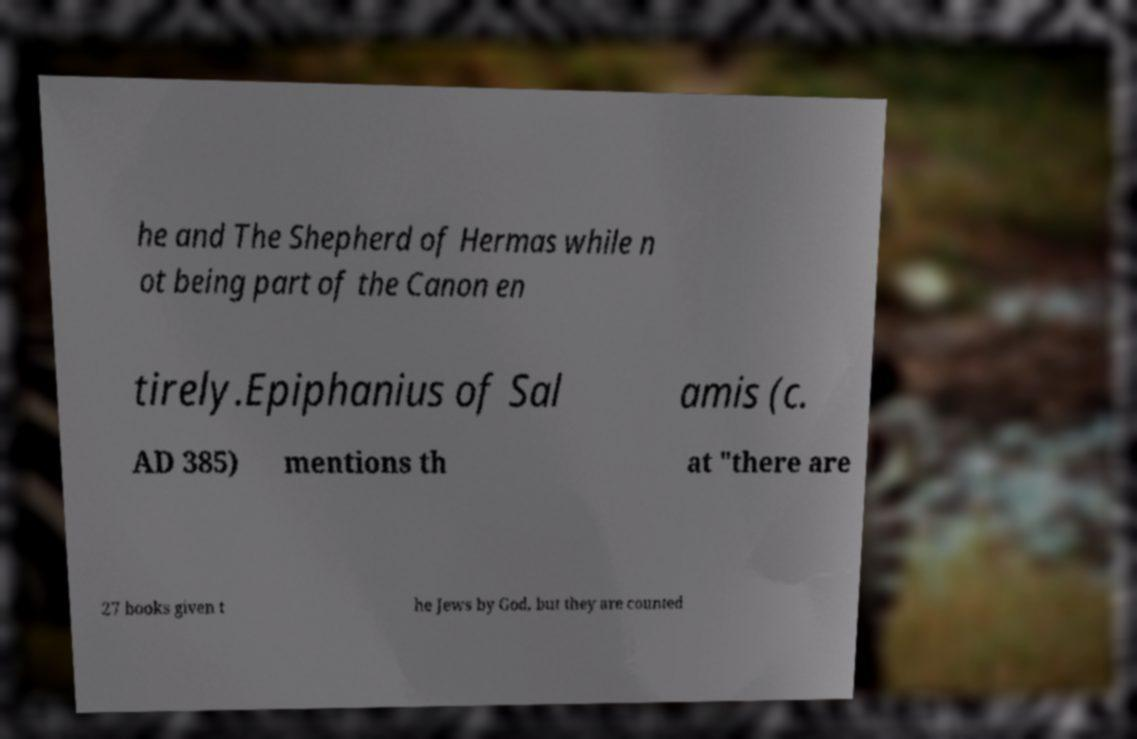Could you assist in decoding the text presented in this image and type it out clearly? he and The Shepherd of Hermas while n ot being part of the Canon en tirely.Epiphanius of Sal amis (c. AD 385) mentions th at "there are 27 books given t he Jews by God, but they are counted 